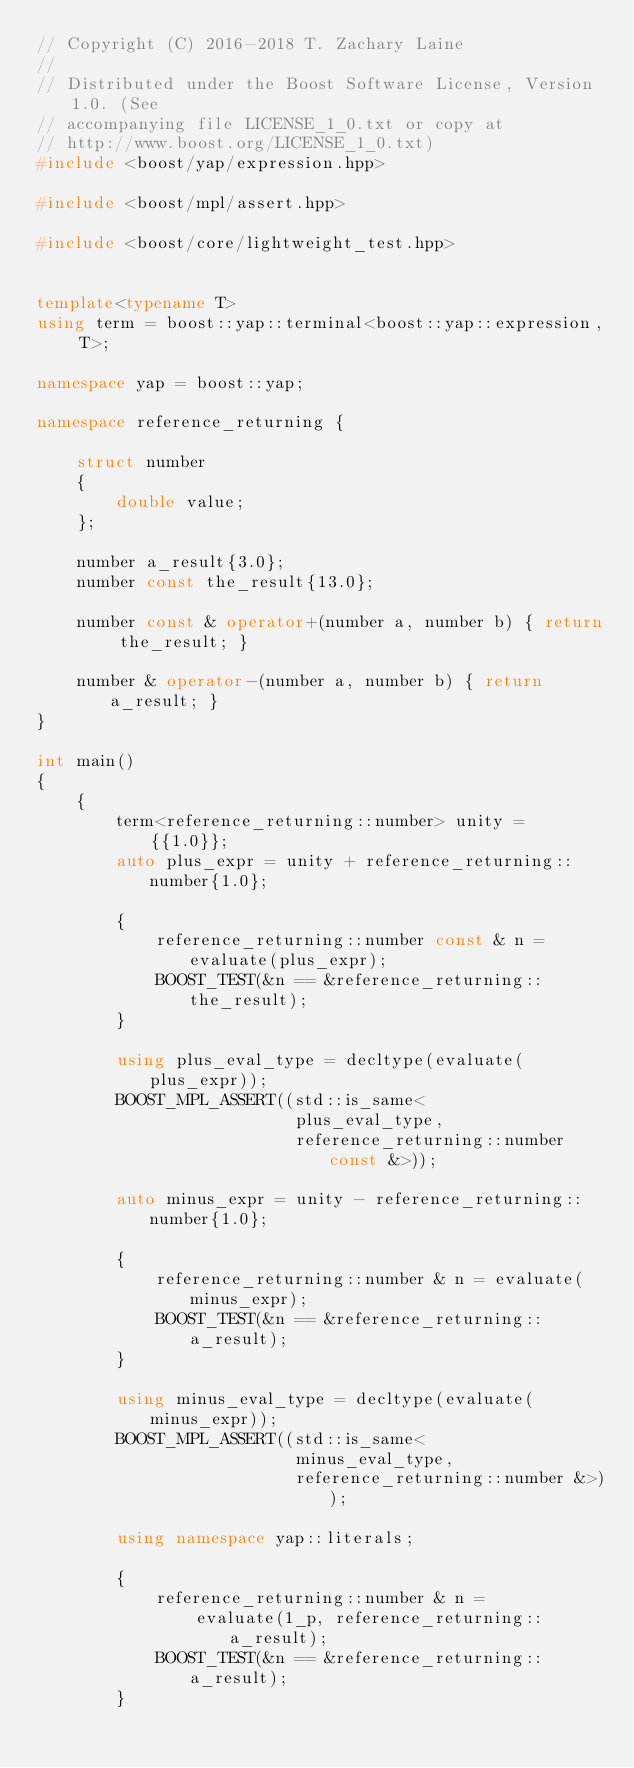Convert code to text. <code><loc_0><loc_0><loc_500><loc_500><_C++_>// Copyright (C) 2016-2018 T. Zachary Laine
//
// Distributed under the Boost Software License, Version 1.0. (See
// accompanying file LICENSE_1_0.txt or copy at
// http://www.boost.org/LICENSE_1_0.txt)
#include <boost/yap/expression.hpp>

#include <boost/mpl/assert.hpp>

#include <boost/core/lightweight_test.hpp>


template<typename T>
using term = boost::yap::terminal<boost::yap::expression, T>;

namespace yap = boost::yap;

namespace reference_returning {

    struct number
    {
        double value;
    };

    number a_result{3.0};
    number const the_result{13.0};

    number const & operator+(number a, number b) { return the_result; }

    number & operator-(number a, number b) { return a_result; }
}

int main()
{
    {
        term<reference_returning::number> unity = {{1.0}};
        auto plus_expr = unity + reference_returning::number{1.0};

        {
            reference_returning::number const & n = evaluate(plus_expr);
            BOOST_TEST(&n == &reference_returning::the_result);
        }

        using plus_eval_type = decltype(evaluate(plus_expr));
        BOOST_MPL_ASSERT((std::is_same<
                          plus_eval_type,
                          reference_returning::number const &>));

        auto minus_expr = unity - reference_returning::number{1.0};

        {
            reference_returning::number & n = evaluate(minus_expr);
            BOOST_TEST(&n == &reference_returning::a_result);
        }

        using minus_eval_type = decltype(evaluate(minus_expr));
        BOOST_MPL_ASSERT((std::is_same<
                          minus_eval_type,
                          reference_returning::number &>));

        using namespace yap::literals;

        {
            reference_returning::number & n =
                evaluate(1_p, reference_returning::a_result);
            BOOST_TEST(&n == &reference_returning::a_result);
        }
</code> 